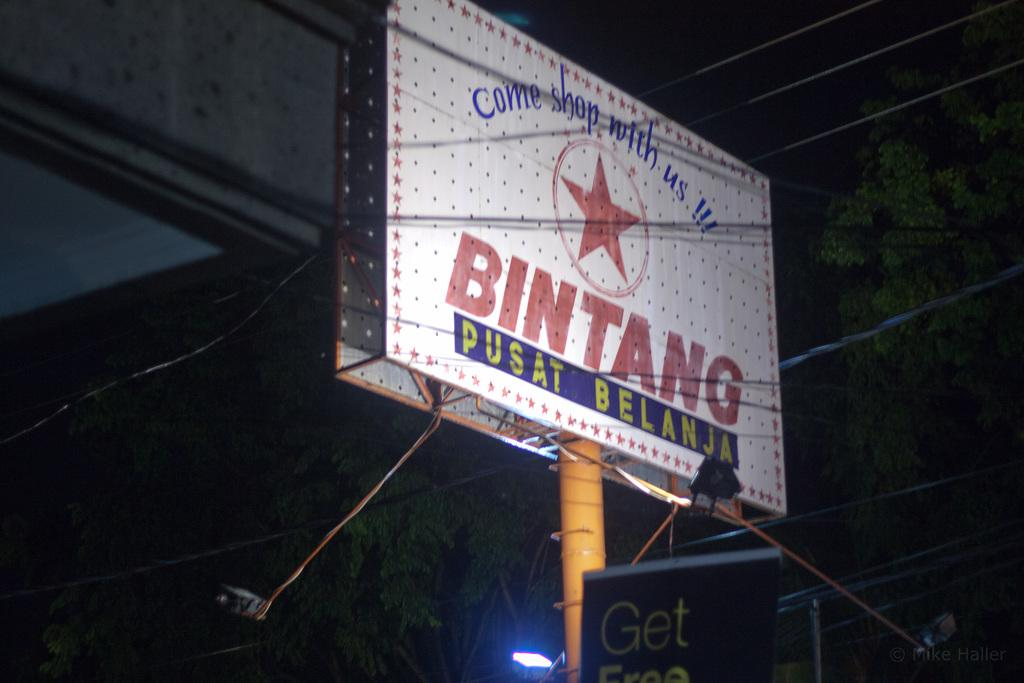<image>
Describe the image concisely. A tall, white billboard with Bintang and a red star on the center of it. 